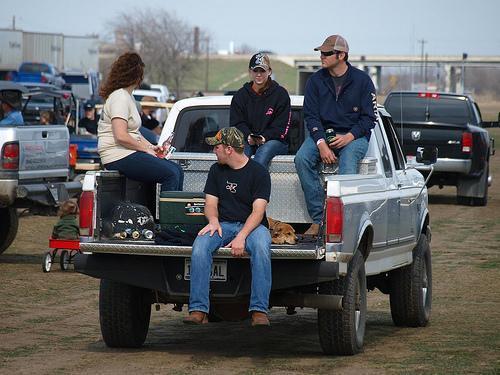How many are women?
Give a very brief answer. 2. 